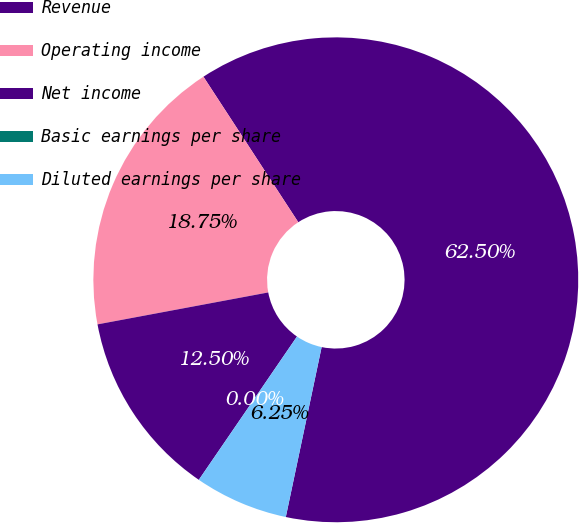Convert chart. <chart><loc_0><loc_0><loc_500><loc_500><pie_chart><fcel>Revenue<fcel>Operating income<fcel>Net income<fcel>Basic earnings per share<fcel>Diluted earnings per share<nl><fcel>62.5%<fcel>18.75%<fcel>12.5%<fcel>0.0%<fcel>6.25%<nl></chart> 